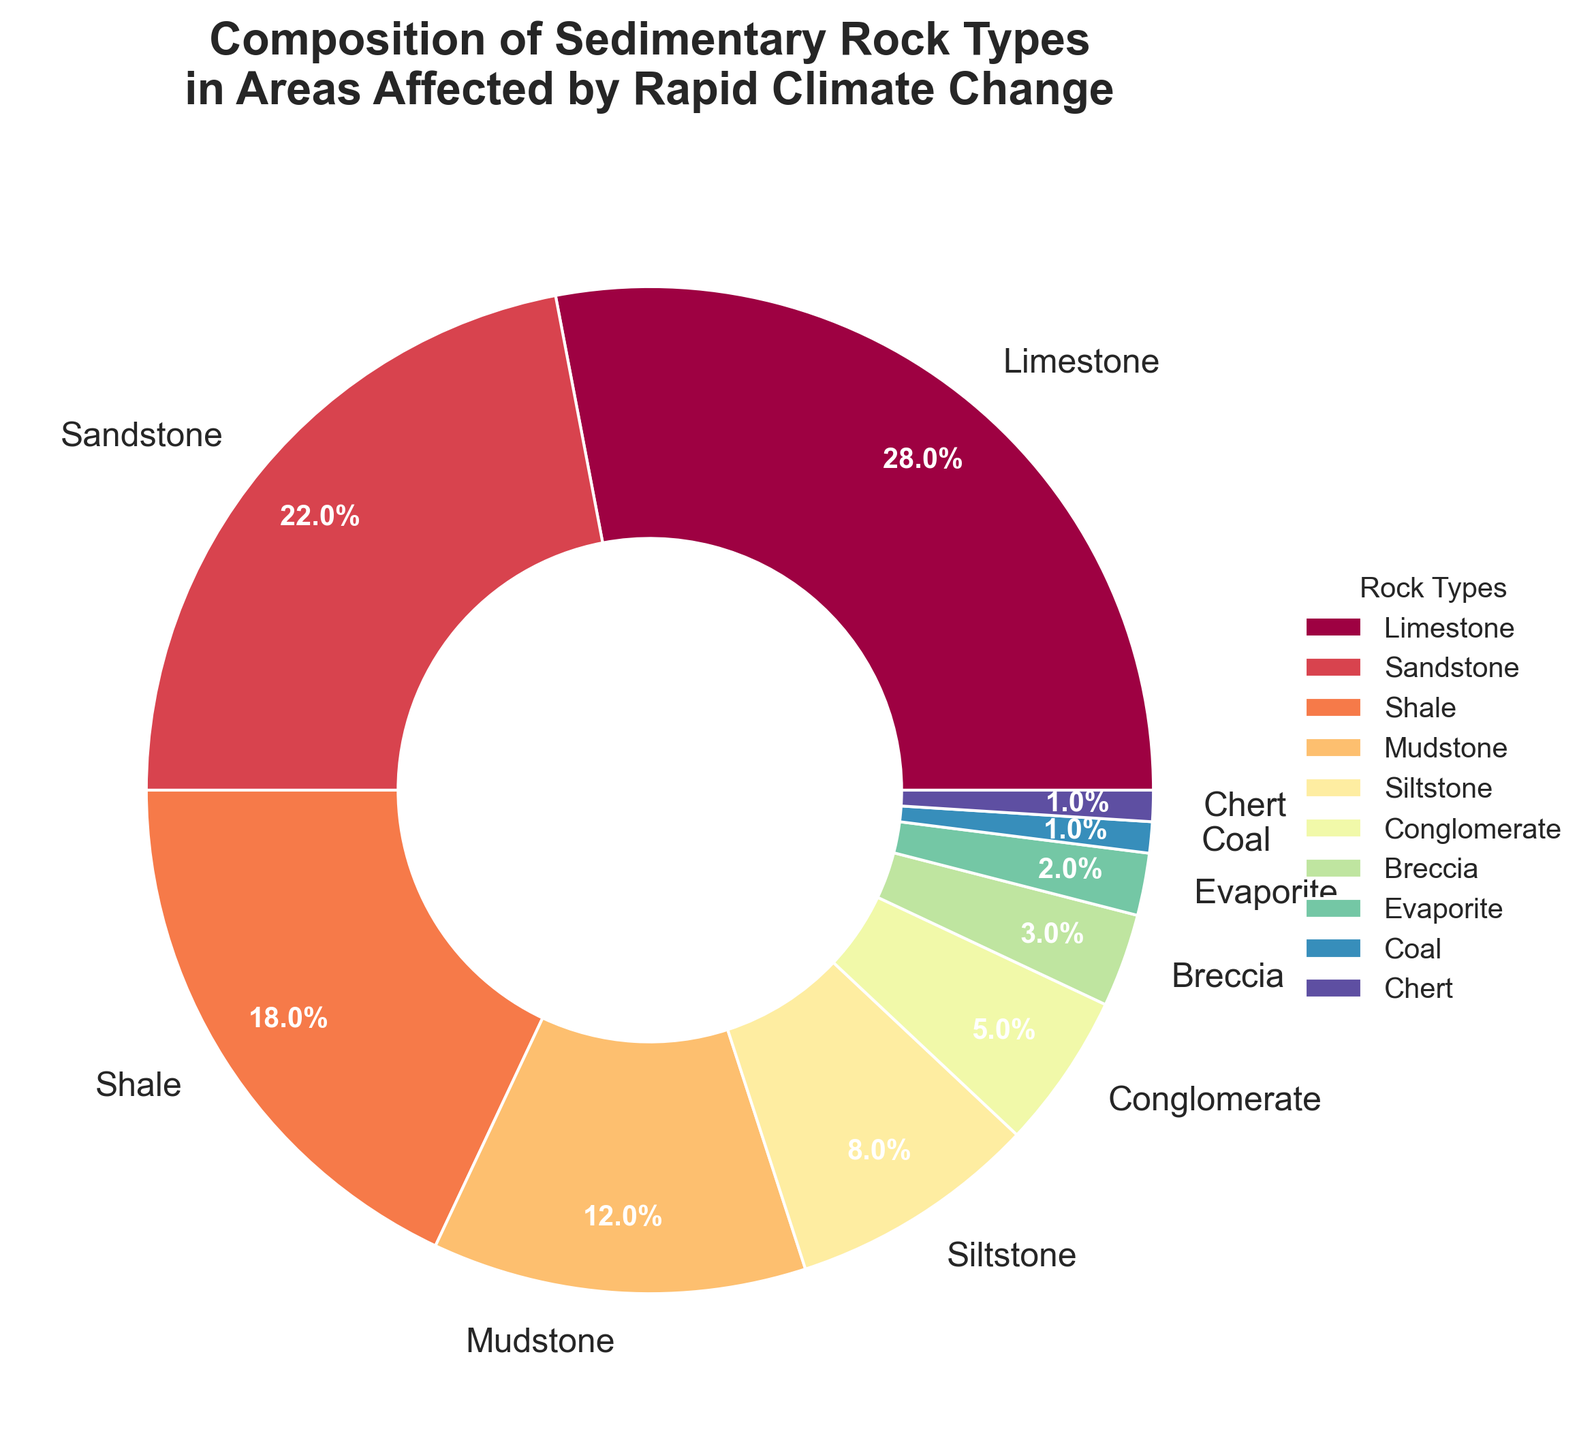What is the combined percentage of Limestone and Sandstone? To find the combined percentage of Limestone and Sandstone, simply add the percentages of each type: 28% (Limestone) + 22% (Sandstone) = 50%.
Answer: 50% Which rock type has the lowest percentage in the composition? By examining the percentages of each rock type, we observe that both Coal and Chert have the lowest percentage, each having 1%.
Answer: Coal and Chert Is Mudstone's percentage greater than Siltstone's percentage? Mudstone's percentage is 12%, whereas Siltstone's percentage is 8%. By comparing these values, we see that 12% is greater than 8%.
Answer: Yes Which rock type has a higher percentage, Shale or Sandstone? By comparing the percentages, we see that Shale has a percentage of 18%, while Sandstone has 22%. Therefore, Sandstone has a higher percentage than Shale.
Answer: Sandstone What is the total percentage of rock types having a percentage less than 10%? Identify rock types with percentages below 10% and sum their values: Siltstone (8%) + Conglomerate (5%) + Breccia (3%) + Evaporite (2%) + Coal (1%) + Chert (1%) = 20%.
Answer: 20% What percentage of the composition is made up by Evaporite and Coal together? Add the percentages of Evaporite (2%) and Coal (1%): 2% + 1% = 3%.
Answer: 3% Which rock type is represented with the highest percentage in the pie chart? By observing the chart, Limestone has the highest percentage, which is 28%.
Answer: Limestone Is the percentage of Mudstone and Siltstone together greater than Sandstone? Sum the percentages of Mudstone (12%) and Siltstone (8%): 12% + 8% = 20%, which is less than the percentage of Sandstone (22%).
Answer: No Among the listed rock types, which two have the closest percentage values? Looking at the percentages, Mudstone (12%) and Siltstone (8%) are the closest in numerical difference (4%).
Answer: Mudstone and Siltstone Does the combined percentage of Coal, Chert, and Evaporite exceed 5%? Add the percentages of Coal (1%), Chert (1%), and Evaporite (2%): 1% + 1% + 2% = 4%, which is less than 5%.
Answer: No 